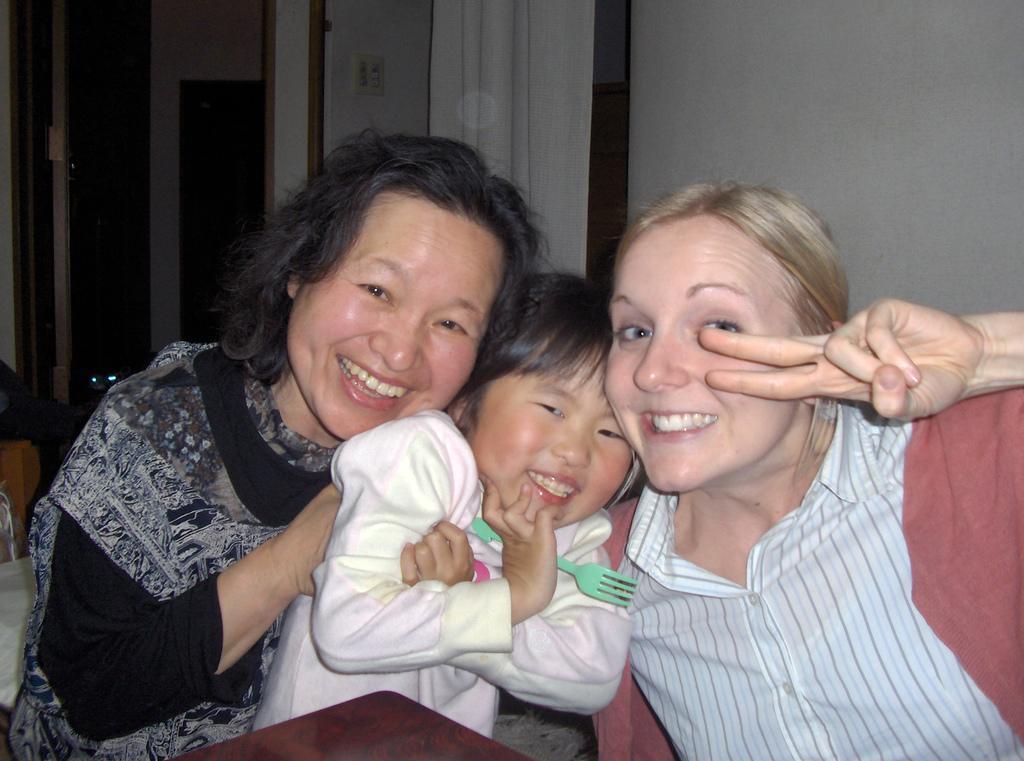How would you summarize this image in a sentence or two? In this image, we can see two women and a kid sitting, they are smiling, in the background we can see a wall and a curtain. 